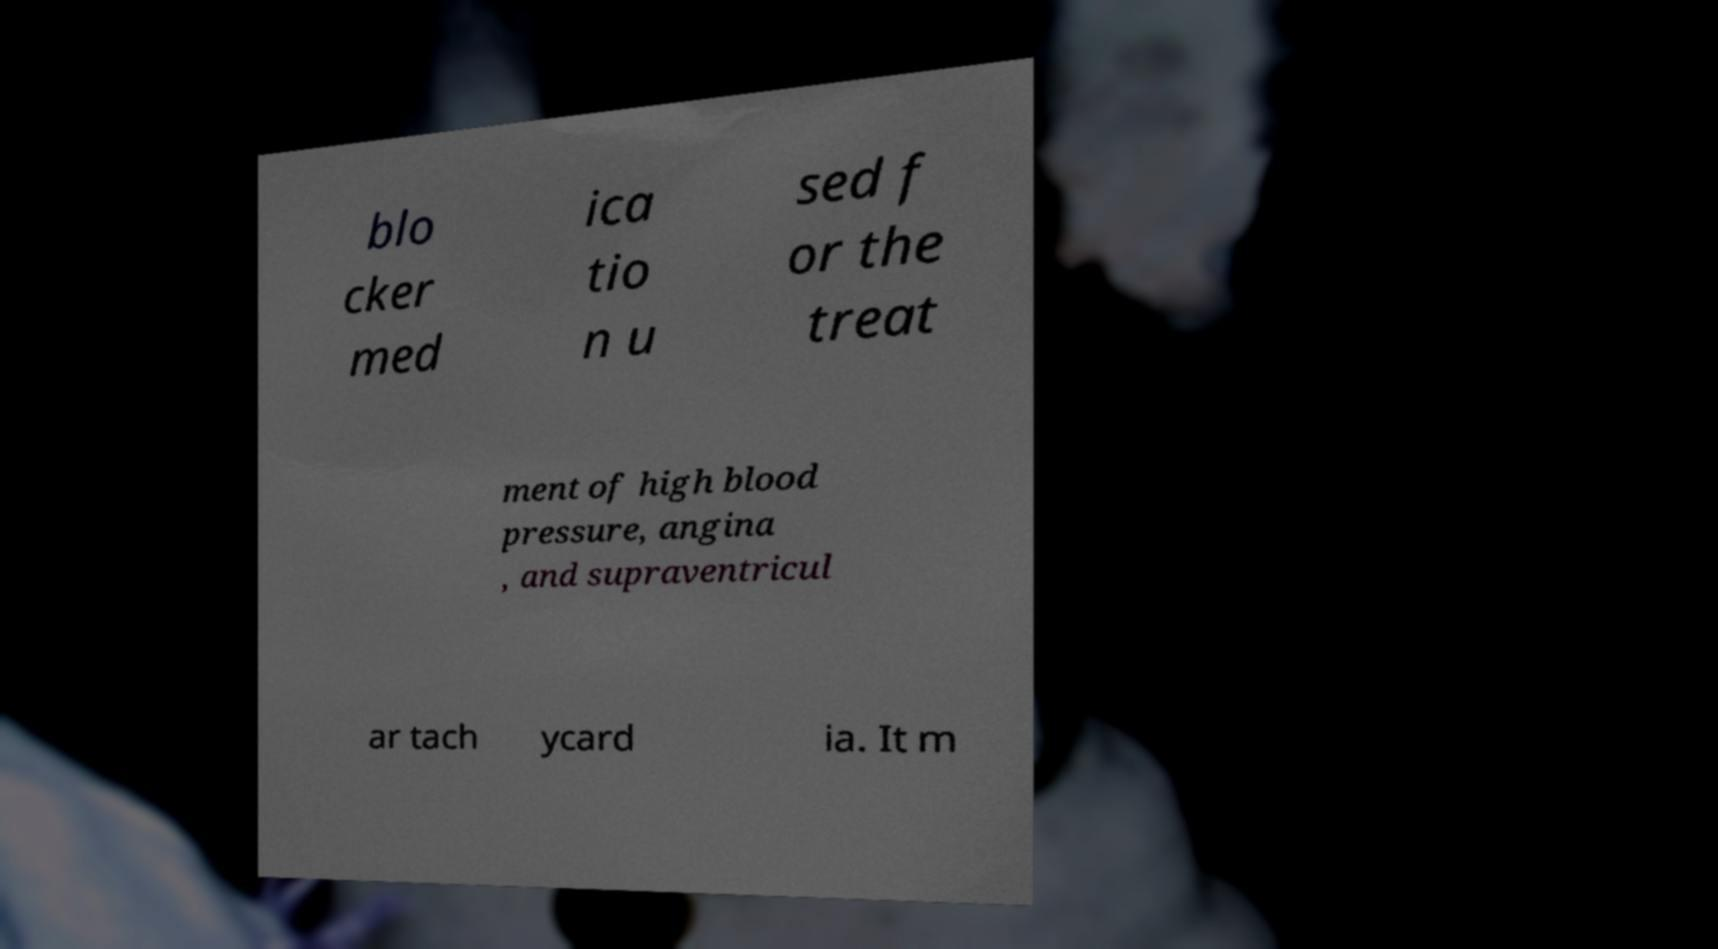Can you accurately transcribe the text from the provided image for me? blo cker med ica tio n u sed f or the treat ment of high blood pressure, angina , and supraventricul ar tach ycard ia. It m 